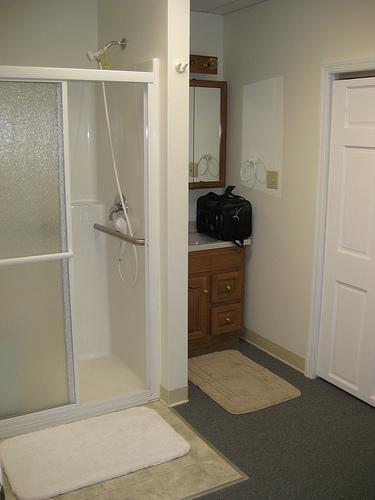How many people could fit in that carry on bag?
Give a very brief answer. 0. 